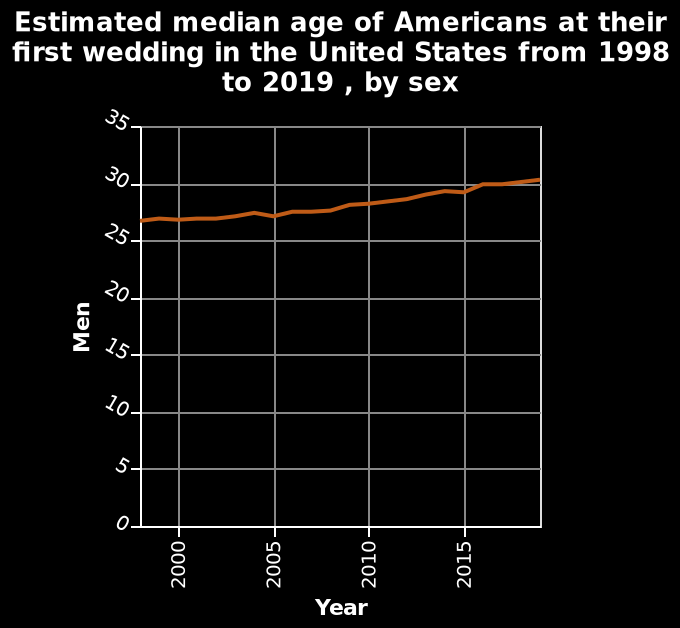<image>
What does the y-axis plot in this line graph? The y-axis plots the median age of men at their first wedding. Has the median age of Americans at their first wedding in the United States increased or decreased between 2000 and 2015? The median age of Americans at their first wedding in the United States has increased between 2000 and 2015. 